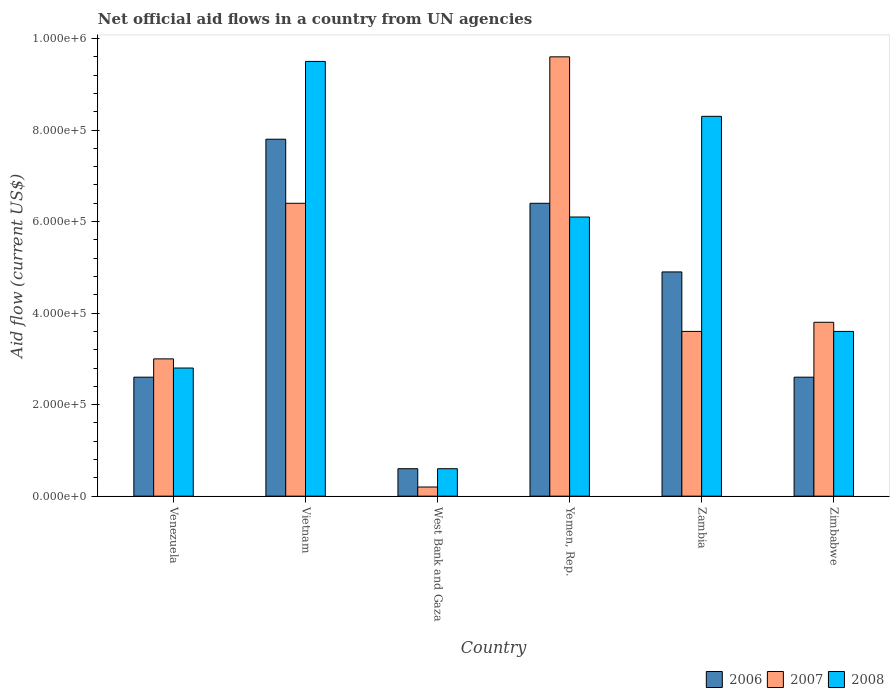How many different coloured bars are there?
Your response must be concise. 3. How many groups of bars are there?
Offer a terse response. 6. Are the number of bars per tick equal to the number of legend labels?
Offer a terse response. Yes. Are the number of bars on each tick of the X-axis equal?
Give a very brief answer. Yes. How many bars are there on the 1st tick from the left?
Your answer should be very brief. 3. How many bars are there on the 3rd tick from the right?
Offer a very short reply. 3. What is the label of the 6th group of bars from the left?
Keep it short and to the point. Zimbabwe. What is the net official aid flow in 2008 in Vietnam?
Provide a succinct answer. 9.50e+05. Across all countries, what is the maximum net official aid flow in 2008?
Offer a terse response. 9.50e+05. Across all countries, what is the minimum net official aid flow in 2006?
Your response must be concise. 6.00e+04. In which country was the net official aid flow in 2006 maximum?
Make the answer very short. Vietnam. In which country was the net official aid flow in 2007 minimum?
Your answer should be very brief. West Bank and Gaza. What is the total net official aid flow in 2008 in the graph?
Make the answer very short. 3.09e+06. What is the difference between the net official aid flow in 2008 in Vietnam and that in West Bank and Gaza?
Provide a succinct answer. 8.90e+05. What is the difference between the net official aid flow in 2007 in Venezuela and the net official aid flow in 2008 in Zimbabwe?
Offer a very short reply. -6.00e+04. What is the average net official aid flow in 2008 per country?
Offer a very short reply. 5.15e+05. In how many countries, is the net official aid flow in 2006 greater than 640000 US$?
Make the answer very short. 1. What is the ratio of the net official aid flow in 2008 in Venezuela to that in Zambia?
Offer a very short reply. 0.34. Is the difference between the net official aid flow in 2008 in Vietnam and West Bank and Gaza greater than the difference between the net official aid flow in 2006 in Vietnam and West Bank and Gaza?
Keep it short and to the point. Yes. What is the difference between the highest and the second highest net official aid flow in 2007?
Provide a short and direct response. 3.20e+05. What is the difference between the highest and the lowest net official aid flow in 2008?
Keep it short and to the point. 8.90e+05. How many bars are there?
Give a very brief answer. 18. Are all the bars in the graph horizontal?
Make the answer very short. No. How many countries are there in the graph?
Ensure brevity in your answer.  6. What is the difference between two consecutive major ticks on the Y-axis?
Your answer should be very brief. 2.00e+05. Are the values on the major ticks of Y-axis written in scientific E-notation?
Your response must be concise. Yes. Does the graph contain grids?
Offer a very short reply. No. How are the legend labels stacked?
Offer a very short reply. Horizontal. What is the title of the graph?
Give a very brief answer. Net official aid flows in a country from UN agencies. Does "1994" appear as one of the legend labels in the graph?
Your response must be concise. No. What is the label or title of the X-axis?
Keep it short and to the point. Country. What is the Aid flow (current US$) in 2006 in Venezuela?
Your answer should be compact. 2.60e+05. What is the Aid flow (current US$) of 2008 in Venezuela?
Provide a short and direct response. 2.80e+05. What is the Aid flow (current US$) in 2006 in Vietnam?
Keep it short and to the point. 7.80e+05. What is the Aid flow (current US$) of 2007 in Vietnam?
Keep it short and to the point. 6.40e+05. What is the Aid flow (current US$) in 2008 in Vietnam?
Make the answer very short. 9.50e+05. What is the Aid flow (current US$) of 2006 in West Bank and Gaza?
Make the answer very short. 6.00e+04. What is the Aid flow (current US$) of 2006 in Yemen, Rep.?
Keep it short and to the point. 6.40e+05. What is the Aid flow (current US$) in 2007 in Yemen, Rep.?
Your answer should be compact. 9.60e+05. What is the Aid flow (current US$) in 2008 in Yemen, Rep.?
Your answer should be very brief. 6.10e+05. What is the Aid flow (current US$) in 2006 in Zambia?
Make the answer very short. 4.90e+05. What is the Aid flow (current US$) of 2008 in Zambia?
Ensure brevity in your answer.  8.30e+05. What is the Aid flow (current US$) in 2006 in Zimbabwe?
Give a very brief answer. 2.60e+05. What is the Aid flow (current US$) in 2008 in Zimbabwe?
Keep it short and to the point. 3.60e+05. Across all countries, what is the maximum Aid flow (current US$) in 2006?
Offer a very short reply. 7.80e+05. Across all countries, what is the maximum Aid flow (current US$) in 2007?
Provide a succinct answer. 9.60e+05. Across all countries, what is the maximum Aid flow (current US$) of 2008?
Offer a terse response. 9.50e+05. Across all countries, what is the minimum Aid flow (current US$) of 2007?
Offer a very short reply. 2.00e+04. What is the total Aid flow (current US$) of 2006 in the graph?
Ensure brevity in your answer.  2.49e+06. What is the total Aid flow (current US$) in 2007 in the graph?
Make the answer very short. 2.66e+06. What is the total Aid flow (current US$) in 2008 in the graph?
Provide a succinct answer. 3.09e+06. What is the difference between the Aid flow (current US$) of 2006 in Venezuela and that in Vietnam?
Offer a very short reply. -5.20e+05. What is the difference between the Aid flow (current US$) of 2008 in Venezuela and that in Vietnam?
Your response must be concise. -6.70e+05. What is the difference between the Aid flow (current US$) in 2006 in Venezuela and that in West Bank and Gaza?
Offer a very short reply. 2.00e+05. What is the difference between the Aid flow (current US$) in 2008 in Venezuela and that in West Bank and Gaza?
Make the answer very short. 2.20e+05. What is the difference between the Aid flow (current US$) of 2006 in Venezuela and that in Yemen, Rep.?
Keep it short and to the point. -3.80e+05. What is the difference between the Aid flow (current US$) of 2007 in Venezuela and that in Yemen, Rep.?
Provide a succinct answer. -6.60e+05. What is the difference between the Aid flow (current US$) in 2008 in Venezuela and that in Yemen, Rep.?
Ensure brevity in your answer.  -3.30e+05. What is the difference between the Aid flow (current US$) in 2008 in Venezuela and that in Zambia?
Your answer should be very brief. -5.50e+05. What is the difference between the Aid flow (current US$) of 2006 in Venezuela and that in Zimbabwe?
Your answer should be very brief. 0. What is the difference between the Aid flow (current US$) of 2006 in Vietnam and that in West Bank and Gaza?
Make the answer very short. 7.20e+05. What is the difference between the Aid flow (current US$) of 2007 in Vietnam and that in West Bank and Gaza?
Provide a short and direct response. 6.20e+05. What is the difference between the Aid flow (current US$) of 2008 in Vietnam and that in West Bank and Gaza?
Your answer should be very brief. 8.90e+05. What is the difference between the Aid flow (current US$) in 2006 in Vietnam and that in Yemen, Rep.?
Your response must be concise. 1.40e+05. What is the difference between the Aid flow (current US$) in 2007 in Vietnam and that in Yemen, Rep.?
Provide a short and direct response. -3.20e+05. What is the difference between the Aid flow (current US$) in 2006 in Vietnam and that in Zambia?
Keep it short and to the point. 2.90e+05. What is the difference between the Aid flow (current US$) in 2007 in Vietnam and that in Zambia?
Provide a short and direct response. 2.80e+05. What is the difference between the Aid flow (current US$) in 2008 in Vietnam and that in Zambia?
Make the answer very short. 1.20e+05. What is the difference between the Aid flow (current US$) of 2006 in Vietnam and that in Zimbabwe?
Offer a terse response. 5.20e+05. What is the difference between the Aid flow (current US$) in 2008 in Vietnam and that in Zimbabwe?
Your answer should be compact. 5.90e+05. What is the difference between the Aid flow (current US$) in 2006 in West Bank and Gaza and that in Yemen, Rep.?
Keep it short and to the point. -5.80e+05. What is the difference between the Aid flow (current US$) in 2007 in West Bank and Gaza and that in Yemen, Rep.?
Keep it short and to the point. -9.40e+05. What is the difference between the Aid flow (current US$) of 2008 in West Bank and Gaza and that in Yemen, Rep.?
Provide a succinct answer. -5.50e+05. What is the difference between the Aid flow (current US$) in 2006 in West Bank and Gaza and that in Zambia?
Your answer should be compact. -4.30e+05. What is the difference between the Aid flow (current US$) in 2008 in West Bank and Gaza and that in Zambia?
Give a very brief answer. -7.70e+05. What is the difference between the Aid flow (current US$) in 2006 in West Bank and Gaza and that in Zimbabwe?
Your response must be concise. -2.00e+05. What is the difference between the Aid flow (current US$) of 2007 in West Bank and Gaza and that in Zimbabwe?
Provide a succinct answer. -3.60e+05. What is the difference between the Aid flow (current US$) in 2008 in West Bank and Gaza and that in Zimbabwe?
Offer a very short reply. -3.00e+05. What is the difference between the Aid flow (current US$) in 2008 in Yemen, Rep. and that in Zambia?
Keep it short and to the point. -2.20e+05. What is the difference between the Aid flow (current US$) in 2007 in Yemen, Rep. and that in Zimbabwe?
Provide a short and direct response. 5.80e+05. What is the difference between the Aid flow (current US$) of 2006 in Zambia and that in Zimbabwe?
Give a very brief answer. 2.30e+05. What is the difference between the Aid flow (current US$) in 2007 in Zambia and that in Zimbabwe?
Keep it short and to the point. -2.00e+04. What is the difference between the Aid flow (current US$) in 2008 in Zambia and that in Zimbabwe?
Offer a terse response. 4.70e+05. What is the difference between the Aid flow (current US$) of 2006 in Venezuela and the Aid flow (current US$) of 2007 in Vietnam?
Your answer should be compact. -3.80e+05. What is the difference between the Aid flow (current US$) in 2006 in Venezuela and the Aid flow (current US$) in 2008 in Vietnam?
Make the answer very short. -6.90e+05. What is the difference between the Aid flow (current US$) in 2007 in Venezuela and the Aid flow (current US$) in 2008 in Vietnam?
Make the answer very short. -6.50e+05. What is the difference between the Aid flow (current US$) of 2006 in Venezuela and the Aid flow (current US$) of 2007 in West Bank and Gaza?
Give a very brief answer. 2.40e+05. What is the difference between the Aid flow (current US$) of 2007 in Venezuela and the Aid flow (current US$) of 2008 in West Bank and Gaza?
Keep it short and to the point. 2.40e+05. What is the difference between the Aid flow (current US$) in 2006 in Venezuela and the Aid flow (current US$) in 2007 in Yemen, Rep.?
Keep it short and to the point. -7.00e+05. What is the difference between the Aid flow (current US$) in 2006 in Venezuela and the Aid flow (current US$) in 2008 in Yemen, Rep.?
Your response must be concise. -3.50e+05. What is the difference between the Aid flow (current US$) of 2007 in Venezuela and the Aid flow (current US$) of 2008 in Yemen, Rep.?
Offer a very short reply. -3.10e+05. What is the difference between the Aid flow (current US$) in 2006 in Venezuela and the Aid flow (current US$) in 2007 in Zambia?
Offer a very short reply. -1.00e+05. What is the difference between the Aid flow (current US$) in 2006 in Venezuela and the Aid flow (current US$) in 2008 in Zambia?
Provide a short and direct response. -5.70e+05. What is the difference between the Aid flow (current US$) in 2007 in Venezuela and the Aid flow (current US$) in 2008 in Zambia?
Your response must be concise. -5.30e+05. What is the difference between the Aid flow (current US$) in 2007 in Venezuela and the Aid flow (current US$) in 2008 in Zimbabwe?
Provide a succinct answer. -6.00e+04. What is the difference between the Aid flow (current US$) of 2006 in Vietnam and the Aid flow (current US$) of 2007 in West Bank and Gaza?
Make the answer very short. 7.60e+05. What is the difference between the Aid flow (current US$) in 2006 in Vietnam and the Aid flow (current US$) in 2008 in West Bank and Gaza?
Provide a succinct answer. 7.20e+05. What is the difference between the Aid flow (current US$) in 2007 in Vietnam and the Aid flow (current US$) in 2008 in West Bank and Gaza?
Your response must be concise. 5.80e+05. What is the difference between the Aid flow (current US$) of 2006 in Vietnam and the Aid flow (current US$) of 2007 in Yemen, Rep.?
Offer a very short reply. -1.80e+05. What is the difference between the Aid flow (current US$) in 2006 in Vietnam and the Aid flow (current US$) in 2008 in Yemen, Rep.?
Give a very brief answer. 1.70e+05. What is the difference between the Aid flow (current US$) of 2006 in Vietnam and the Aid flow (current US$) of 2008 in Zambia?
Provide a short and direct response. -5.00e+04. What is the difference between the Aid flow (current US$) of 2007 in Vietnam and the Aid flow (current US$) of 2008 in Zambia?
Offer a terse response. -1.90e+05. What is the difference between the Aid flow (current US$) in 2007 in Vietnam and the Aid flow (current US$) in 2008 in Zimbabwe?
Make the answer very short. 2.80e+05. What is the difference between the Aid flow (current US$) of 2006 in West Bank and Gaza and the Aid flow (current US$) of 2007 in Yemen, Rep.?
Offer a very short reply. -9.00e+05. What is the difference between the Aid flow (current US$) of 2006 in West Bank and Gaza and the Aid flow (current US$) of 2008 in Yemen, Rep.?
Keep it short and to the point. -5.50e+05. What is the difference between the Aid flow (current US$) in 2007 in West Bank and Gaza and the Aid flow (current US$) in 2008 in Yemen, Rep.?
Give a very brief answer. -5.90e+05. What is the difference between the Aid flow (current US$) in 2006 in West Bank and Gaza and the Aid flow (current US$) in 2007 in Zambia?
Make the answer very short. -3.00e+05. What is the difference between the Aid flow (current US$) of 2006 in West Bank and Gaza and the Aid flow (current US$) of 2008 in Zambia?
Provide a succinct answer. -7.70e+05. What is the difference between the Aid flow (current US$) in 2007 in West Bank and Gaza and the Aid flow (current US$) in 2008 in Zambia?
Provide a succinct answer. -8.10e+05. What is the difference between the Aid flow (current US$) in 2006 in West Bank and Gaza and the Aid flow (current US$) in 2007 in Zimbabwe?
Your answer should be compact. -3.20e+05. What is the difference between the Aid flow (current US$) in 2006 in West Bank and Gaza and the Aid flow (current US$) in 2008 in Zimbabwe?
Offer a very short reply. -3.00e+05. What is the difference between the Aid flow (current US$) of 2006 in Yemen, Rep. and the Aid flow (current US$) of 2007 in Zimbabwe?
Your answer should be very brief. 2.60e+05. What is the difference between the Aid flow (current US$) of 2007 in Yemen, Rep. and the Aid flow (current US$) of 2008 in Zimbabwe?
Give a very brief answer. 6.00e+05. What is the difference between the Aid flow (current US$) in 2006 in Zambia and the Aid flow (current US$) in 2007 in Zimbabwe?
Your response must be concise. 1.10e+05. What is the average Aid flow (current US$) in 2006 per country?
Keep it short and to the point. 4.15e+05. What is the average Aid flow (current US$) in 2007 per country?
Your answer should be compact. 4.43e+05. What is the average Aid flow (current US$) in 2008 per country?
Provide a succinct answer. 5.15e+05. What is the difference between the Aid flow (current US$) of 2006 and Aid flow (current US$) of 2007 in Venezuela?
Your answer should be very brief. -4.00e+04. What is the difference between the Aid flow (current US$) in 2007 and Aid flow (current US$) in 2008 in Venezuela?
Give a very brief answer. 2.00e+04. What is the difference between the Aid flow (current US$) of 2006 and Aid flow (current US$) of 2008 in Vietnam?
Keep it short and to the point. -1.70e+05. What is the difference between the Aid flow (current US$) of 2007 and Aid flow (current US$) of 2008 in Vietnam?
Your answer should be very brief. -3.10e+05. What is the difference between the Aid flow (current US$) of 2006 and Aid flow (current US$) of 2007 in Yemen, Rep.?
Ensure brevity in your answer.  -3.20e+05. What is the difference between the Aid flow (current US$) of 2006 and Aid flow (current US$) of 2008 in Yemen, Rep.?
Keep it short and to the point. 3.00e+04. What is the difference between the Aid flow (current US$) of 2006 and Aid flow (current US$) of 2007 in Zambia?
Keep it short and to the point. 1.30e+05. What is the difference between the Aid flow (current US$) of 2007 and Aid flow (current US$) of 2008 in Zambia?
Your answer should be compact. -4.70e+05. What is the ratio of the Aid flow (current US$) in 2006 in Venezuela to that in Vietnam?
Your answer should be very brief. 0.33. What is the ratio of the Aid flow (current US$) in 2007 in Venezuela to that in Vietnam?
Make the answer very short. 0.47. What is the ratio of the Aid flow (current US$) in 2008 in Venezuela to that in Vietnam?
Keep it short and to the point. 0.29. What is the ratio of the Aid flow (current US$) of 2006 in Venezuela to that in West Bank and Gaza?
Ensure brevity in your answer.  4.33. What is the ratio of the Aid flow (current US$) of 2008 in Venezuela to that in West Bank and Gaza?
Keep it short and to the point. 4.67. What is the ratio of the Aid flow (current US$) of 2006 in Venezuela to that in Yemen, Rep.?
Provide a short and direct response. 0.41. What is the ratio of the Aid flow (current US$) of 2007 in Venezuela to that in Yemen, Rep.?
Your answer should be very brief. 0.31. What is the ratio of the Aid flow (current US$) of 2008 in Venezuela to that in Yemen, Rep.?
Provide a succinct answer. 0.46. What is the ratio of the Aid flow (current US$) of 2006 in Venezuela to that in Zambia?
Your answer should be compact. 0.53. What is the ratio of the Aid flow (current US$) of 2008 in Venezuela to that in Zambia?
Your answer should be very brief. 0.34. What is the ratio of the Aid flow (current US$) of 2007 in Venezuela to that in Zimbabwe?
Offer a terse response. 0.79. What is the ratio of the Aid flow (current US$) in 2006 in Vietnam to that in West Bank and Gaza?
Offer a terse response. 13. What is the ratio of the Aid flow (current US$) in 2007 in Vietnam to that in West Bank and Gaza?
Ensure brevity in your answer.  32. What is the ratio of the Aid flow (current US$) in 2008 in Vietnam to that in West Bank and Gaza?
Ensure brevity in your answer.  15.83. What is the ratio of the Aid flow (current US$) in 2006 in Vietnam to that in Yemen, Rep.?
Provide a short and direct response. 1.22. What is the ratio of the Aid flow (current US$) in 2007 in Vietnam to that in Yemen, Rep.?
Offer a very short reply. 0.67. What is the ratio of the Aid flow (current US$) in 2008 in Vietnam to that in Yemen, Rep.?
Offer a terse response. 1.56. What is the ratio of the Aid flow (current US$) of 2006 in Vietnam to that in Zambia?
Provide a succinct answer. 1.59. What is the ratio of the Aid flow (current US$) in 2007 in Vietnam to that in Zambia?
Your response must be concise. 1.78. What is the ratio of the Aid flow (current US$) in 2008 in Vietnam to that in Zambia?
Your response must be concise. 1.14. What is the ratio of the Aid flow (current US$) in 2006 in Vietnam to that in Zimbabwe?
Keep it short and to the point. 3. What is the ratio of the Aid flow (current US$) in 2007 in Vietnam to that in Zimbabwe?
Your response must be concise. 1.68. What is the ratio of the Aid flow (current US$) of 2008 in Vietnam to that in Zimbabwe?
Provide a succinct answer. 2.64. What is the ratio of the Aid flow (current US$) of 2006 in West Bank and Gaza to that in Yemen, Rep.?
Give a very brief answer. 0.09. What is the ratio of the Aid flow (current US$) of 2007 in West Bank and Gaza to that in Yemen, Rep.?
Offer a very short reply. 0.02. What is the ratio of the Aid flow (current US$) in 2008 in West Bank and Gaza to that in Yemen, Rep.?
Your answer should be very brief. 0.1. What is the ratio of the Aid flow (current US$) in 2006 in West Bank and Gaza to that in Zambia?
Your response must be concise. 0.12. What is the ratio of the Aid flow (current US$) of 2007 in West Bank and Gaza to that in Zambia?
Offer a terse response. 0.06. What is the ratio of the Aid flow (current US$) of 2008 in West Bank and Gaza to that in Zambia?
Ensure brevity in your answer.  0.07. What is the ratio of the Aid flow (current US$) of 2006 in West Bank and Gaza to that in Zimbabwe?
Keep it short and to the point. 0.23. What is the ratio of the Aid flow (current US$) of 2007 in West Bank and Gaza to that in Zimbabwe?
Provide a short and direct response. 0.05. What is the ratio of the Aid flow (current US$) of 2008 in West Bank and Gaza to that in Zimbabwe?
Provide a succinct answer. 0.17. What is the ratio of the Aid flow (current US$) in 2006 in Yemen, Rep. to that in Zambia?
Your answer should be very brief. 1.31. What is the ratio of the Aid flow (current US$) of 2007 in Yemen, Rep. to that in Zambia?
Offer a terse response. 2.67. What is the ratio of the Aid flow (current US$) in 2008 in Yemen, Rep. to that in Zambia?
Offer a very short reply. 0.73. What is the ratio of the Aid flow (current US$) of 2006 in Yemen, Rep. to that in Zimbabwe?
Give a very brief answer. 2.46. What is the ratio of the Aid flow (current US$) in 2007 in Yemen, Rep. to that in Zimbabwe?
Offer a terse response. 2.53. What is the ratio of the Aid flow (current US$) of 2008 in Yemen, Rep. to that in Zimbabwe?
Keep it short and to the point. 1.69. What is the ratio of the Aid flow (current US$) of 2006 in Zambia to that in Zimbabwe?
Give a very brief answer. 1.88. What is the ratio of the Aid flow (current US$) in 2007 in Zambia to that in Zimbabwe?
Ensure brevity in your answer.  0.95. What is the ratio of the Aid flow (current US$) in 2008 in Zambia to that in Zimbabwe?
Ensure brevity in your answer.  2.31. What is the difference between the highest and the second highest Aid flow (current US$) in 2007?
Your answer should be very brief. 3.20e+05. What is the difference between the highest and the lowest Aid flow (current US$) of 2006?
Your response must be concise. 7.20e+05. What is the difference between the highest and the lowest Aid flow (current US$) of 2007?
Offer a terse response. 9.40e+05. What is the difference between the highest and the lowest Aid flow (current US$) of 2008?
Ensure brevity in your answer.  8.90e+05. 